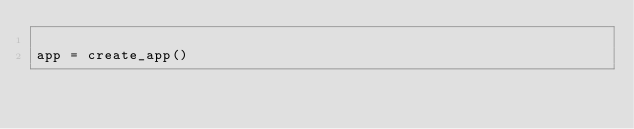Convert code to text. <code><loc_0><loc_0><loc_500><loc_500><_Python_>
app = create_app()
</code> 